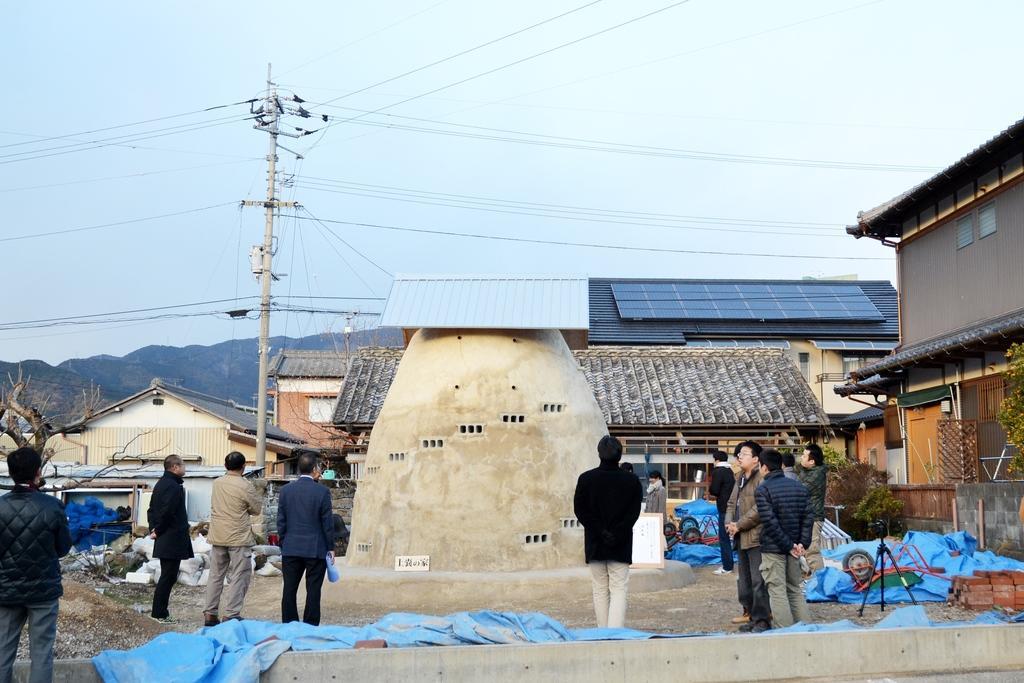Describe this image in one or two sentences. In this image I can see number of people, number of buildings, trees, blue colour things, a pole and number of wires. On the right side of this image I can see number of red colour bricks, a tripod stand and on the left side I can see few white colour things on the ground. I can also see mountains and the sky in the background. 